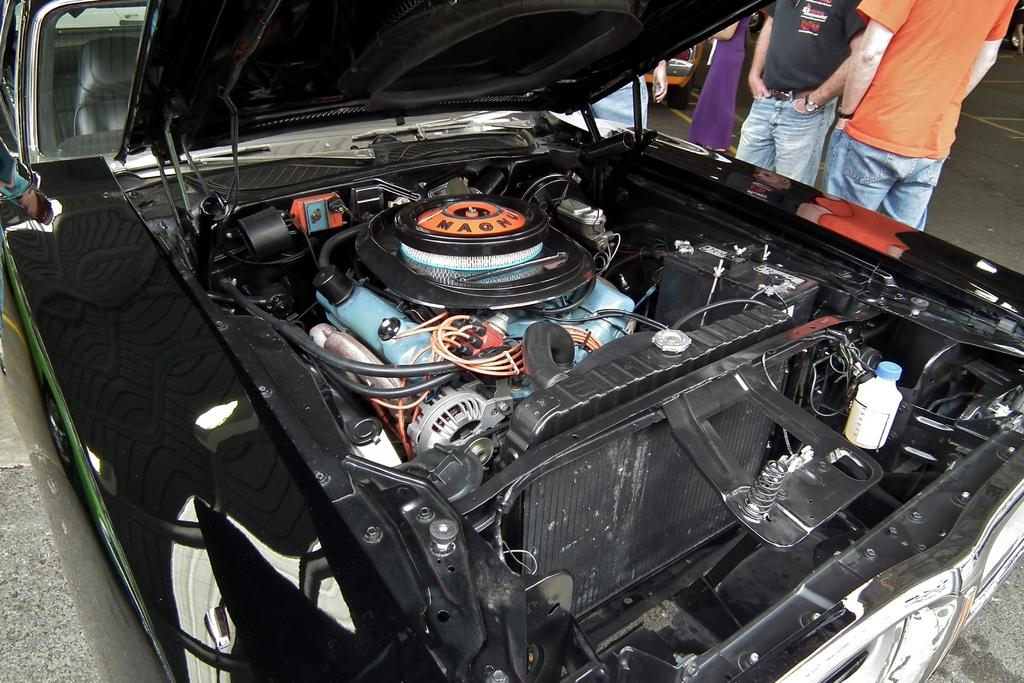What is the main focus of the image? The main focus of the image is a zoomed in picture of a car bonnet. What specific parts of the car bonnet can be seen in the image? There are parts of the car bonnet visible in the image. Can you describe the setting in which the car bonnet is located? There are people in the background of the image, and there is a road at the bottom of the image. What type of nail is being used to form the car bonnet in the image? There is no nail or form present in the image; it is a picture of a car bonnet with no indication of how it was made. 